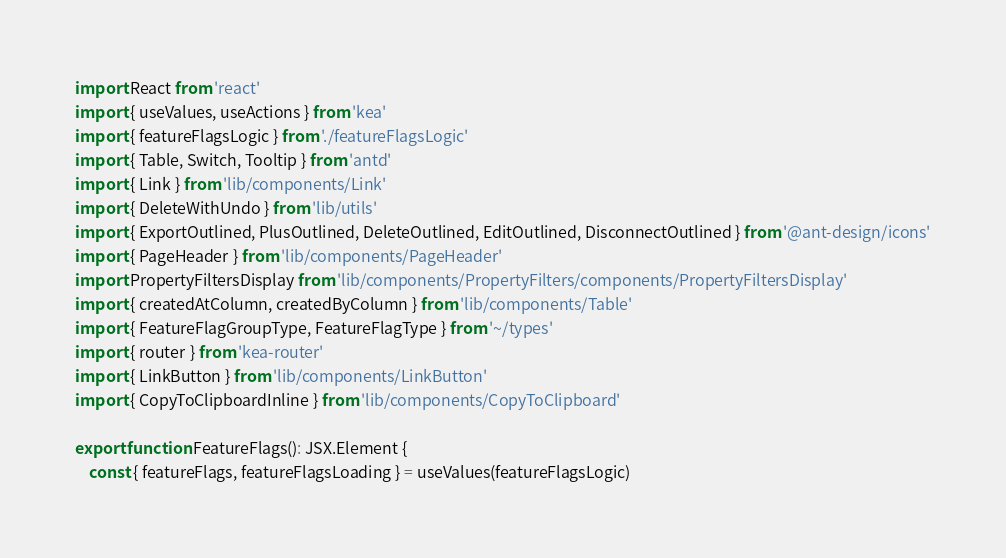<code> <loc_0><loc_0><loc_500><loc_500><_TypeScript_>import React from 'react'
import { useValues, useActions } from 'kea'
import { featureFlagsLogic } from './featureFlagsLogic'
import { Table, Switch, Tooltip } from 'antd'
import { Link } from 'lib/components/Link'
import { DeleteWithUndo } from 'lib/utils'
import { ExportOutlined, PlusOutlined, DeleteOutlined, EditOutlined, DisconnectOutlined } from '@ant-design/icons'
import { PageHeader } from 'lib/components/PageHeader'
import PropertyFiltersDisplay from 'lib/components/PropertyFilters/components/PropertyFiltersDisplay'
import { createdAtColumn, createdByColumn } from 'lib/components/Table'
import { FeatureFlagGroupType, FeatureFlagType } from '~/types'
import { router } from 'kea-router'
import { LinkButton } from 'lib/components/LinkButton'
import { CopyToClipboardInline } from 'lib/components/CopyToClipboard'

export function FeatureFlags(): JSX.Element {
    const { featureFlags, featureFlagsLoading } = useValues(featureFlagsLogic)</code> 